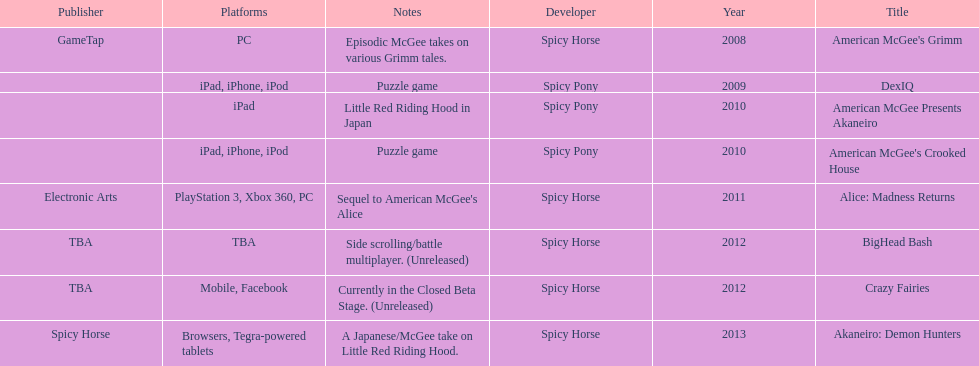What was the exclusive game published by electronic arts? Alice: Madness Returns. 